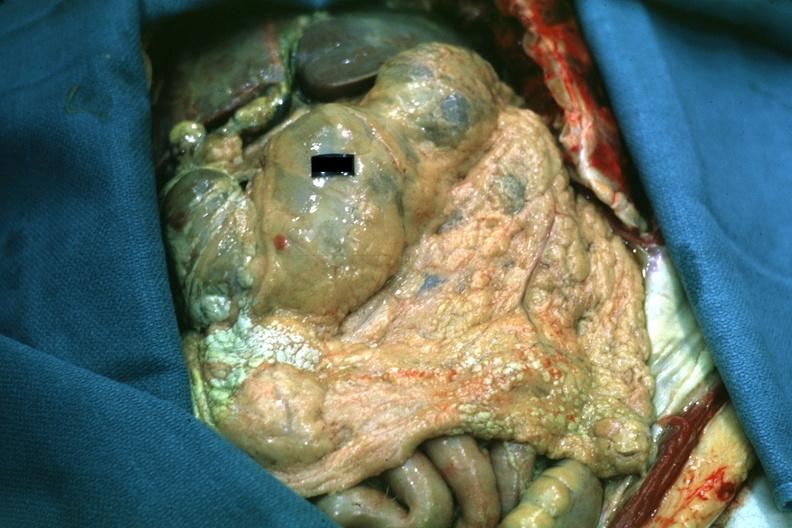what is not clear?
Answer the question using a single word or phrase. All the fat necrosis 